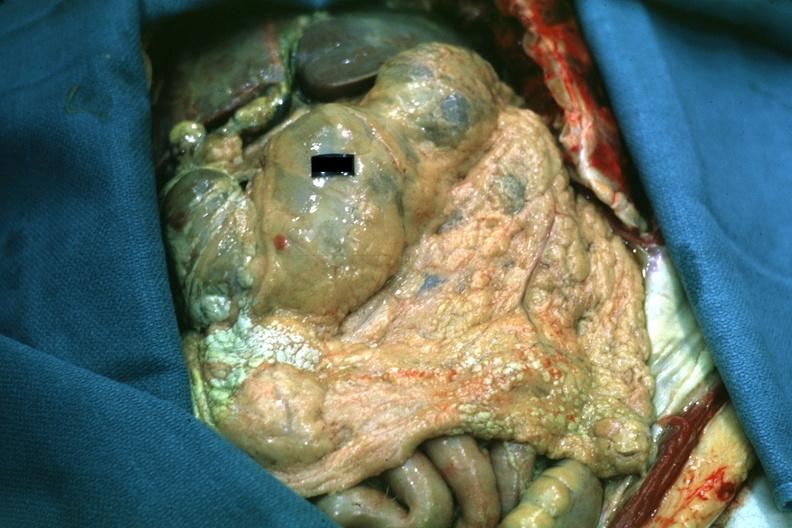what is not clear?
Answer the question using a single word or phrase. All the fat necrosis 